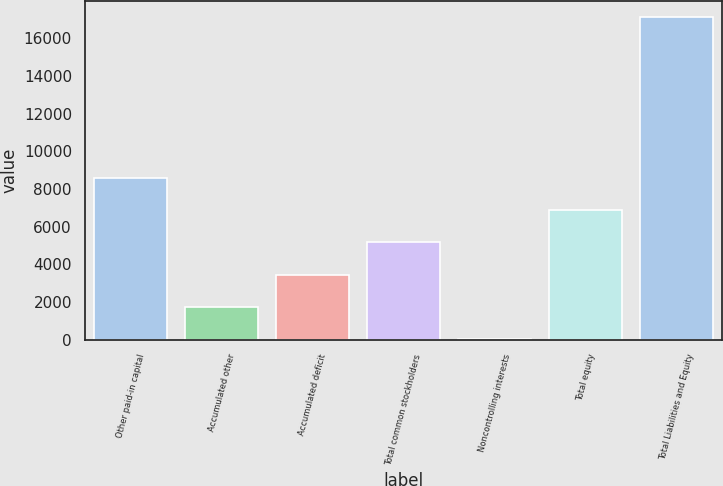<chart> <loc_0><loc_0><loc_500><loc_500><bar_chart><fcel>Other paid-in capital<fcel>Accumulated other<fcel>Accumulated deficit<fcel>Total common stockholders<fcel>Noncontrolling interests<fcel>Total equity<fcel>Total Liabilities and Equity<nl><fcel>8587.5<fcel>1752.7<fcel>3461.4<fcel>5170.1<fcel>44<fcel>6878.8<fcel>17131<nl></chart> 